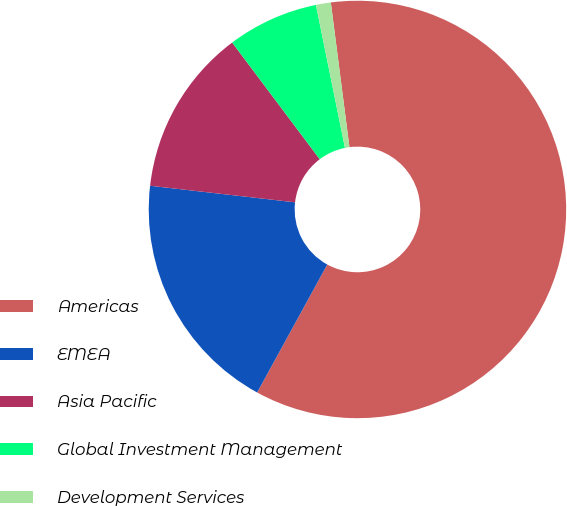<chart> <loc_0><loc_0><loc_500><loc_500><pie_chart><fcel>Americas<fcel>EMEA<fcel>Asia Pacific<fcel>Global Investment Management<fcel>Development Services<nl><fcel>60.01%<fcel>18.83%<fcel>12.94%<fcel>7.06%<fcel>1.15%<nl></chart> 